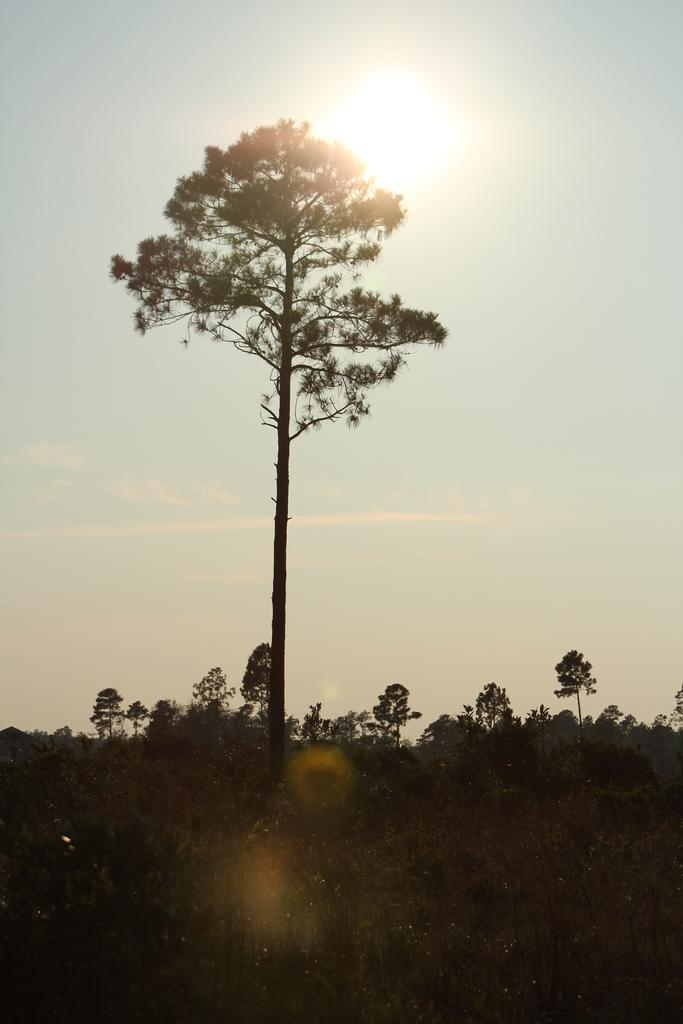What type of vegetation can be seen in the image? There are trees in the image. What part of the natural environment is visible in the image? The sky is visible in the image. What type of apparatus can be seen in the image? There is no apparatus present in the image; it features trees and the sky. What is the reason for the trees being in the image? The image simply shows the presence of trees and the sky, and there is no specific reason provided for their presence. 